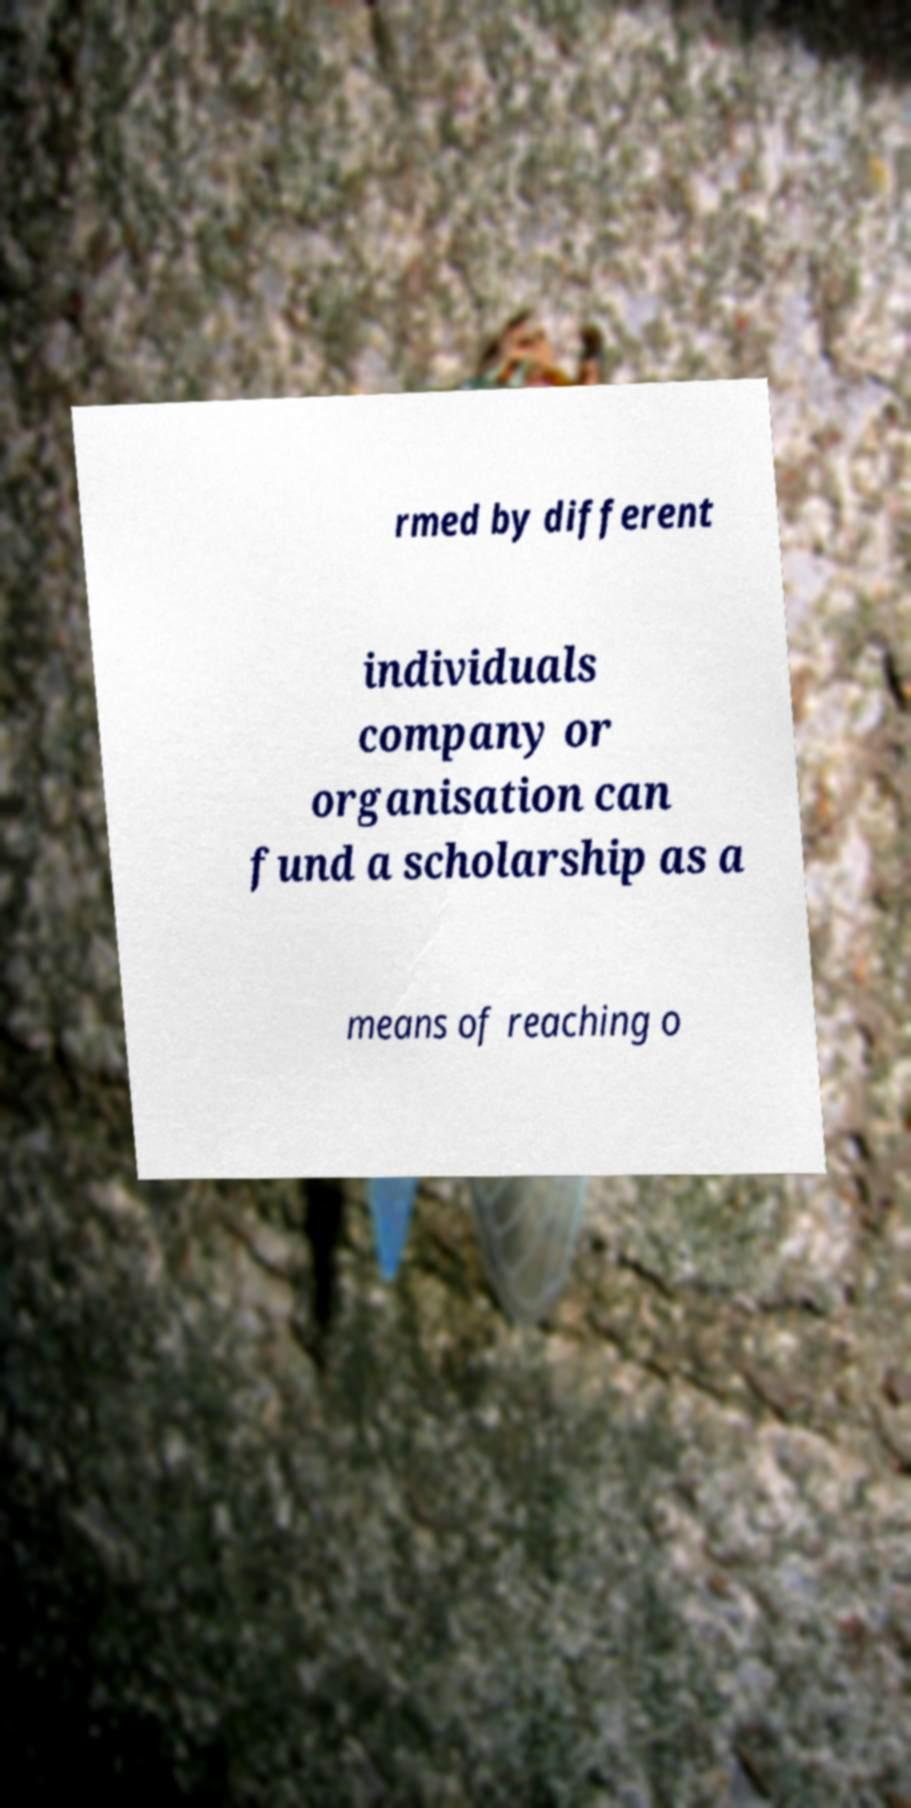Please read and relay the text visible in this image. What does it say? rmed by different individuals company or organisation can fund a scholarship as a means of reaching o 